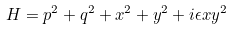Convert formula to latex. <formula><loc_0><loc_0><loc_500><loc_500>H = p ^ { 2 } + q ^ { 2 } + x ^ { 2 } + y ^ { 2 } + i \epsilon x y ^ { 2 }</formula> 